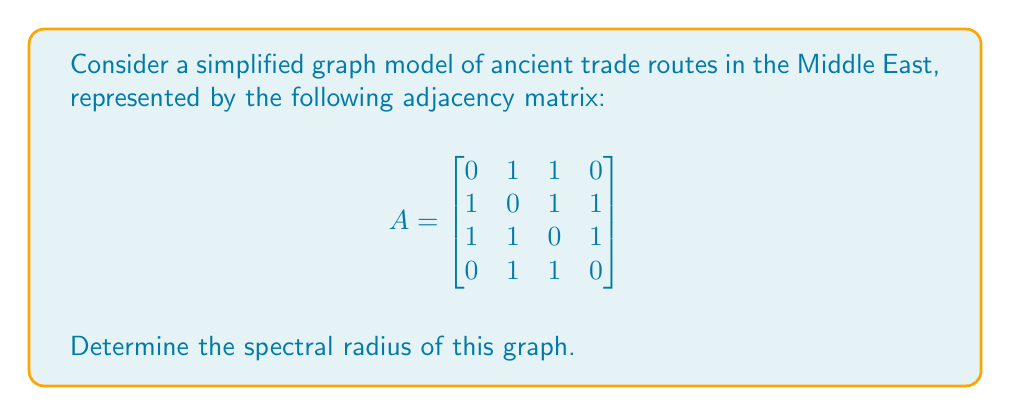Can you solve this math problem? To find the spectral radius of the graph, we need to follow these steps:

1) The spectral radius is the largest absolute eigenvalue of the adjacency matrix.

2) To find the eigenvalues, we need to solve the characteristic equation:
   $$det(A - \lambda I) = 0$$

3) Expanding this determinant:
   $$\begin{vmatrix}
   -\lambda & 1 & 1 & 0 \\
   1 & -\lambda & 1 & 1 \\
   1 & 1 & -\lambda & 1 \\
   0 & 1 & 1 & -\lambda
   \end{vmatrix} = 0$$

4) This expands to the characteristic polynomial:
   $$\lambda^4 - 3\lambda^2 - 4\lambda + 1 = 0$$

5) This fourth-degree polynomial is difficult to solve by hand, so we can use numerical methods or computer algebra systems to find the roots.

6) The roots (eigenvalues) are approximately:
   $\lambda_1 \approx 2.4812$
   $\lambda_2 \approx -1.7321$
   $\lambda_3 \approx 0.5559$
   $\lambda_4 \approx -0.3050$

7) The spectral radius is the largest absolute value among these eigenvalues, which is $|\lambda_1| \approx 2.4812$.
Answer: $2.4812$ (approximately) 